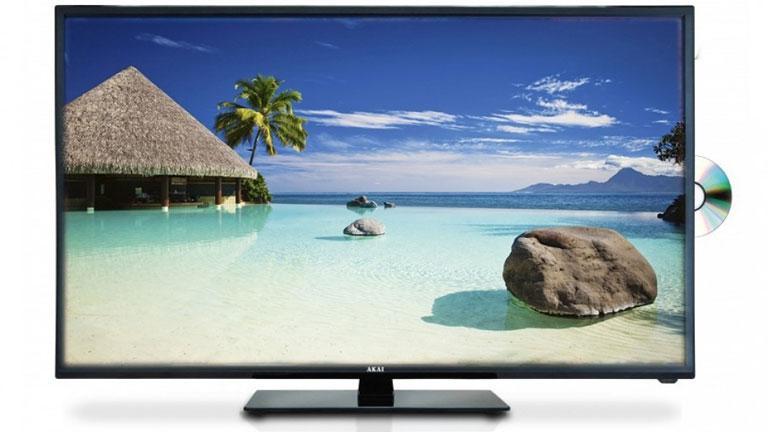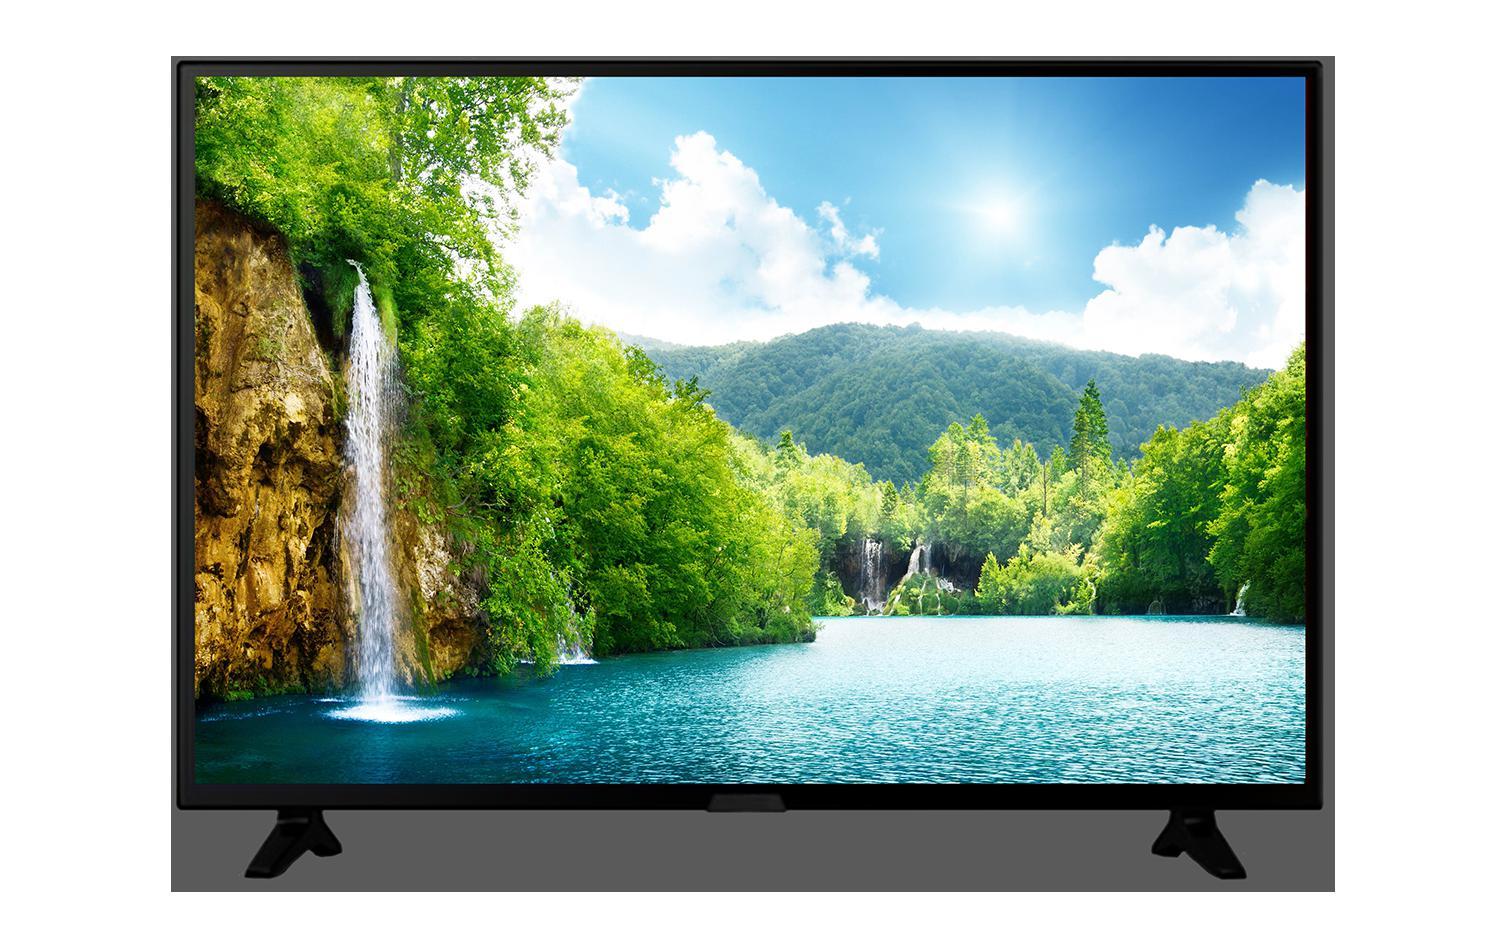The first image is the image on the left, the second image is the image on the right. Evaluate the accuracy of this statement regarding the images: "Each image shows a head-on view of one flat-screen TV on a short black stand, and each TV screen displays a watery blue scene.". Is it true? Answer yes or no. Yes. The first image is the image on the left, the second image is the image on the right. For the images displayed, is the sentence "One television has a pair of end stands." factually correct? Answer yes or no. Yes. 